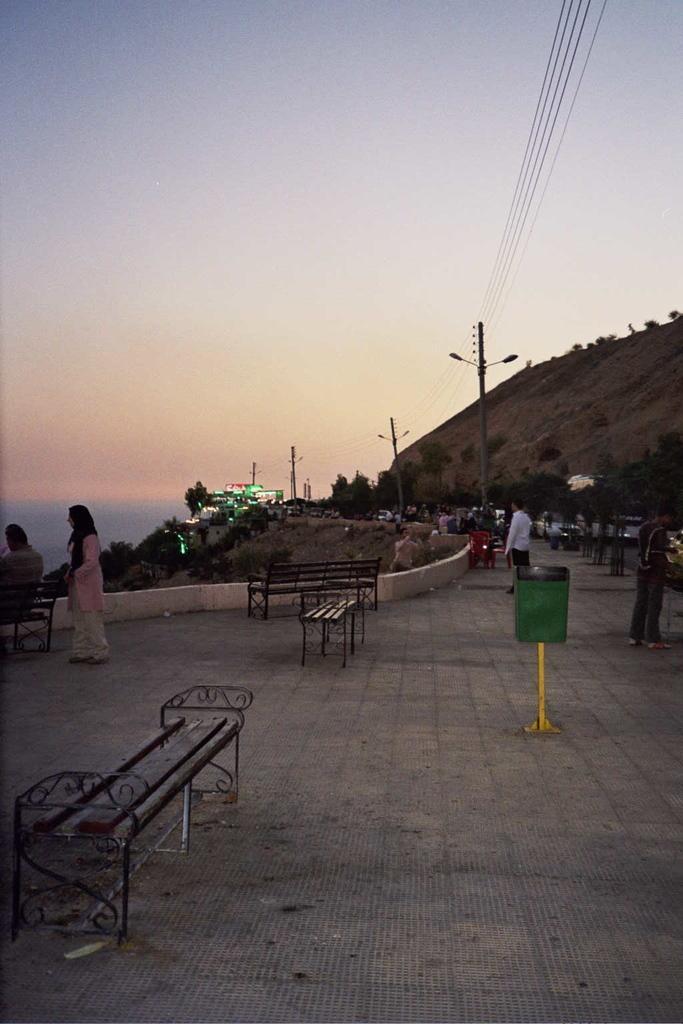Describe this image in one or two sentences. Few persons are standing and this person sitting on the bench. We can see bench,pole with light. A far we can see trees,light,sky. 